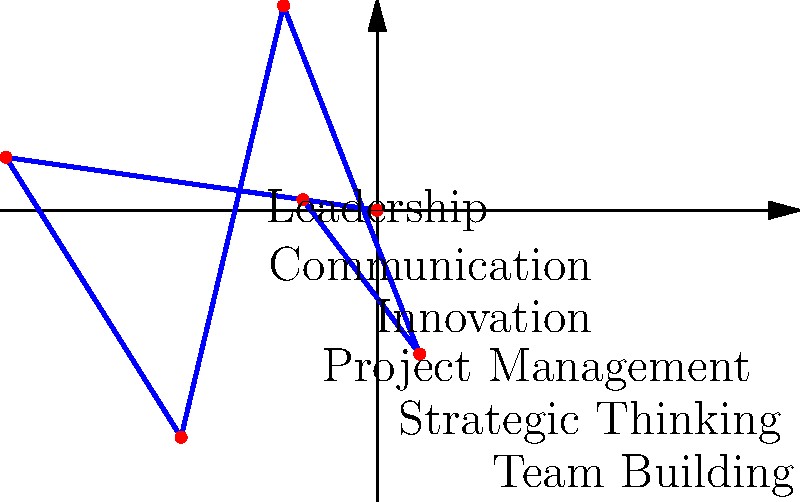In the polar rose diagram representing personal skill growth, which skill area shows the highest level of development, and how might this inform your choice for a second career that aligns with your passions? To answer this question, we need to analyze the polar rose diagram:

1. Identify the skills represented:
   - Leadership (0°)
   - Communication (60°)
   - Innovation (120°)
   - Project Management (180°)
   - Strategic Thinking (240°)
   - Team Building (300°)

2. Compare the radial distance for each skill:
   - Leadership: 4 units
   - Communication: 3 units
   - Innovation: 5 units
   - Project Management: 2 units
   - Strategic Thinking: 4 units
   - Team Building: 3 units

3. Determine the highest level of development:
   Innovation has the largest radial distance at 5 units, indicating the highest level of development.

4. Consider how this might inform a second career choice:
   - As a former executive with strong innovation skills, you might consider roles that leverage this strength.
   - Potential career paths could include:
     a) Innovation consultant
     b) Start-up advisor
     c) Research and development director
     d) Product development manager

5. Align with passions:
   - Reflect on how innovation intersects with your personal interests and values.
   - Consider industries or causes you're passionate about where innovation could make a significant impact.

6. Leverage other strengths:
   - Note that Leadership and Strategic Thinking are also well-developed (4 units each).
   - Look for roles that combine innovation with leadership and strategic planning.
Answer: Innovation; pursue innovation-focused roles that align with personal interests and leverage leadership skills. 